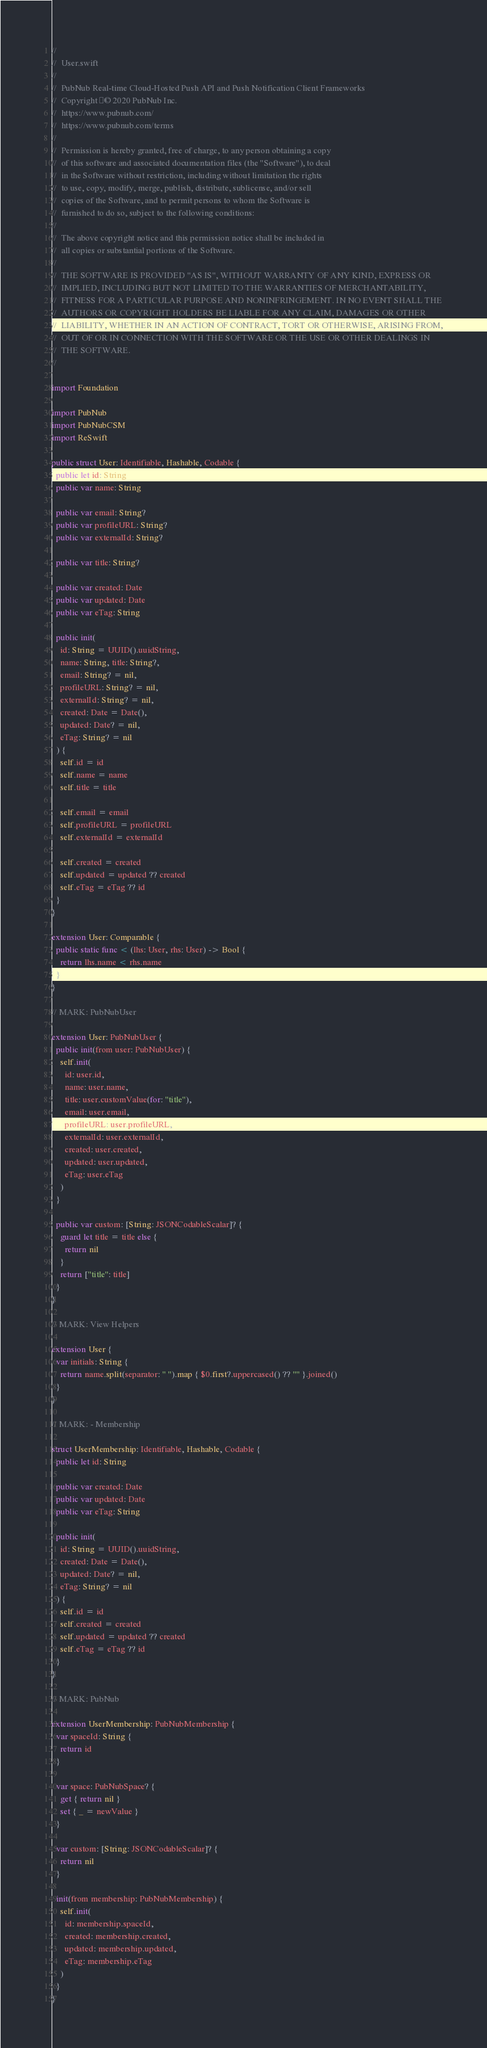Convert code to text. <code><loc_0><loc_0><loc_500><loc_500><_Swift_>//
//  User.swift
//
//  PubNub Real-time Cloud-Hosted Push API and Push Notification Client Frameworks
//  Copyright © 2020 PubNub Inc.
//  https://www.pubnub.com/
//  https://www.pubnub.com/terms
//
//  Permission is hereby granted, free of charge, to any person obtaining a copy
//  of this software and associated documentation files (the "Software"), to deal
//  in the Software without restriction, including without limitation the rights
//  to use, copy, modify, merge, publish, distribute, sublicense, and/or sell
//  copies of the Software, and to permit persons to whom the Software is
//  furnished to do so, subject to the following conditions:
//
//  The above copyright notice and this permission notice shall be included in
//  all copies or substantial portions of the Software.
//
//  THE SOFTWARE IS PROVIDED "AS IS", WITHOUT WARRANTY OF ANY KIND, EXPRESS OR
//  IMPLIED, INCLUDING BUT NOT LIMITED TO THE WARRANTIES OF MERCHANTABILITY,
//  FITNESS FOR A PARTICULAR PURPOSE AND NONINFRINGEMENT. IN NO EVENT SHALL THE
//  AUTHORS OR COPYRIGHT HOLDERS BE LIABLE FOR ANY CLAIM, DAMAGES OR OTHER
//  LIABILITY, WHETHER IN AN ACTION OF CONTRACT, TORT OR OTHERWISE, ARISING FROM,
//  OUT OF OR IN CONNECTION WITH THE SOFTWARE OR THE USE OR OTHER DEALINGS IN
//  THE SOFTWARE.
//

import Foundation

import PubNub
import PubNubCSM
import ReSwift

public struct User: Identifiable, Hashable, Codable {
  public let id: String
  public var name: String

  public var email: String?
  public var profileURL: String?
  public var externalId: String?

  public var title: String?

  public var created: Date
  public var updated: Date
  public var eTag: String

  public init(
    id: String = UUID().uuidString,
    name: String, title: String?,
    email: String? = nil,
    profileURL: String? = nil,
    externalId: String? = nil,
    created: Date = Date(),
    updated: Date? = nil,
    eTag: String? = nil
  ) {
    self.id = id
    self.name = name
    self.title = title

    self.email = email
    self.profileURL = profileURL
    self.externalId = externalId

    self.created = created
    self.updated = updated ?? created
    self.eTag = eTag ?? id
  }
}

extension User: Comparable {
  public static func < (lhs: User, rhs: User) -> Bool {
    return lhs.name < rhs.name
  }
}

// MARK: PubNubUser

extension User: PubNubUser {
  public init(from user: PubNubUser) {
    self.init(
      id: user.id,
      name: user.name,
      title: user.customValue(for: "title"),
      email: user.email,
      profileURL: user.profileURL,
      externalId: user.externalId,
      created: user.created,
      updated: user.updated,
      eTag: user.eTag
    )
  }

  public var custom: [String: JSONCodableScalar]? {
    guard let title = title else {
      return nil
    }
    return ["title": title]
  }
}

// MARK: View Helpers

extension User {
  var initials: String {
    return name.split(separator: " ").map { $0.first?.uppercased() ?? "" }.joined()
  }
}

// MARK: - Membership

struct UserMembership: Identifiable, Hashable, Codable {
  public let id: String

  public var created: Date
  public var updated: Date
  public var eTag: String

  public init(
    id: String = UUID().uuidString,
    created: Date = Date(),
    updated: Date? = nil,
    eTag: String? = nil
  ) {
    self.id = id
    self.created = created
    self.updated = updated ?? created
    self.eTag = eTag ?? id
  }
}

// MARK: PubNub

extension UserMembership: PubNubMembership {
  var spaceId: String {
    return id
  }

  var space: PubNubSpace? {
    get { return nil }
    set { _ = newValue }
  }

  var custom: [String: JSONCodableScalar]? {
    return nil
  }

  init(from membership: PubNubMembership) {
    self.init(
      id: membership.spaceId,
      created: membership.created,
      updated: membership.updated,
      eTag: membership.eTag
    )
  }
}
</code> 